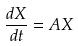<formula> <loc_0><loc_0><loc_500><loc_500>\frac { d X } { d t } = A X</formula> 